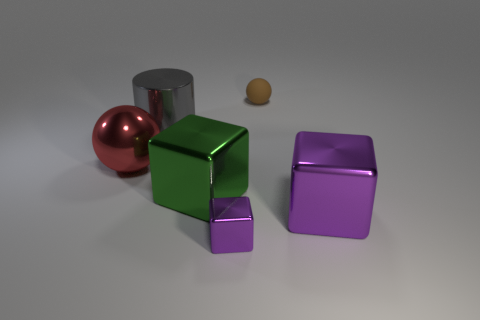If we were to touch the purple cube, what temperature do you think it would be and why? If one were to touch the purple cube, it would likely feel cool to the touch given its metallic appearance. Metals typically conduct heat away from warm objects like human hands, resulting in a sensation of coolness. 